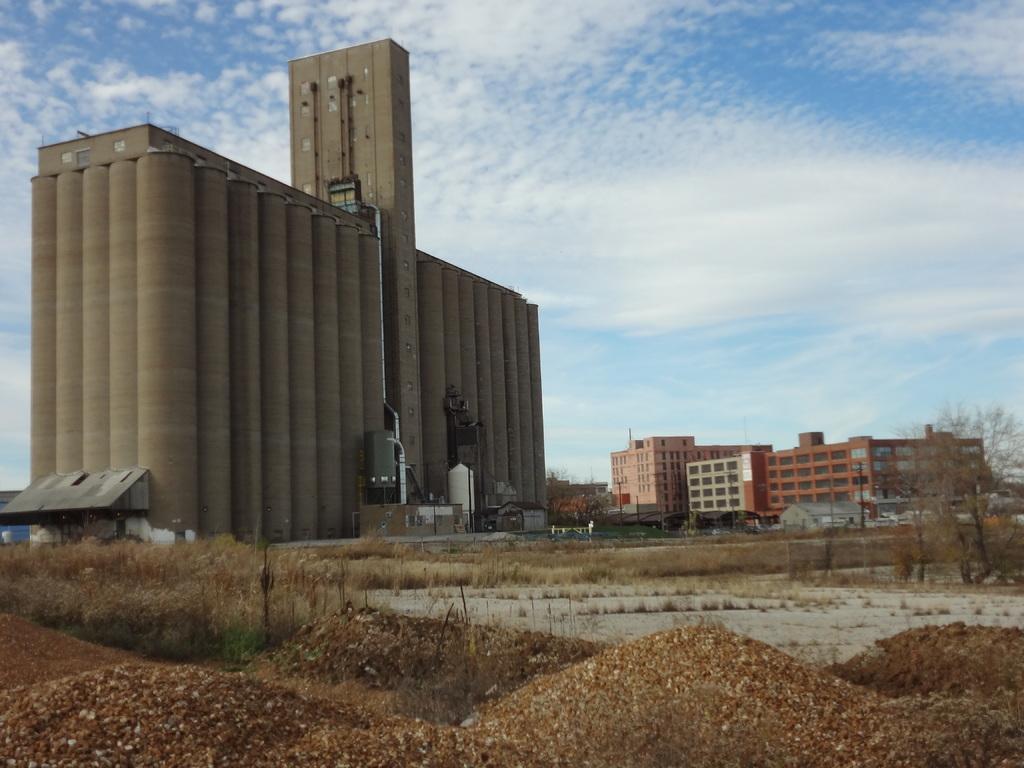Describe this image in one or two sentences. In the image there are buildings in the background, in the front the land is covered with dry grass and plants with small sand dunes and above its sky with clouds. 